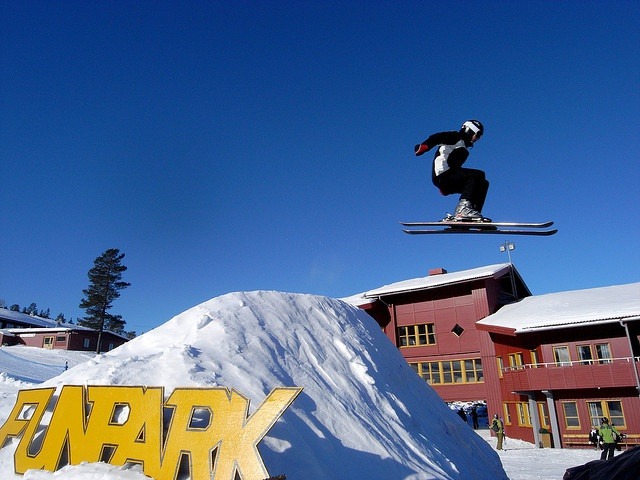Describe the objects in this image and their specific colors. I can see people in darkblue, black, gray, lightgray, and darkgray tones, skis in darkblue, black, gray, and blue tones, people in darkblue, black, olive, and gray tones, people in darkblue, black, olive, gray, and brown tones, and bench in darkblue, gray, tan, and brown tones in this image. 